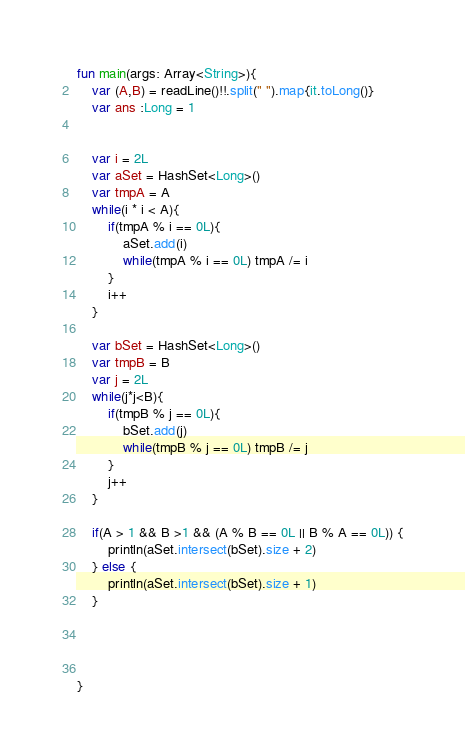Convert code to text. <code><loc_0><loc_0><loc_500><loc_500><_Kotlin_>fun main(args: Array<String>){
    var (A,B) = readLine()!!.split(" ").map{it.toLong()}
    var ans :Long = 1


    var i = 2L
    var aSet = HashSet<Long>()
    var tmpA = A
    while(i * i < A){
        if(tmpA % i == 0L){
            aSet.add(i)
            while(tmpA % i == 0L) tmpA /= i
        }
        i++
    }

    var bSet = HashSet<Long>()
    var tmpB = B
    var j = 2L
    while(j*j<B){
        if(tmpB % j == 0L){
            bSet.add(j)
            while(tmpB % j == 0L) tmpB /= j
        }
        j++
    }

    if(A > 1 && B >1 && (A % B == 0L || B % A == 0L)) {
        println(aSet.intersect(bSet).size + 2)
    } else {
        println(aSet.intersect(bSet).size + 1)
    }




}
</code> 